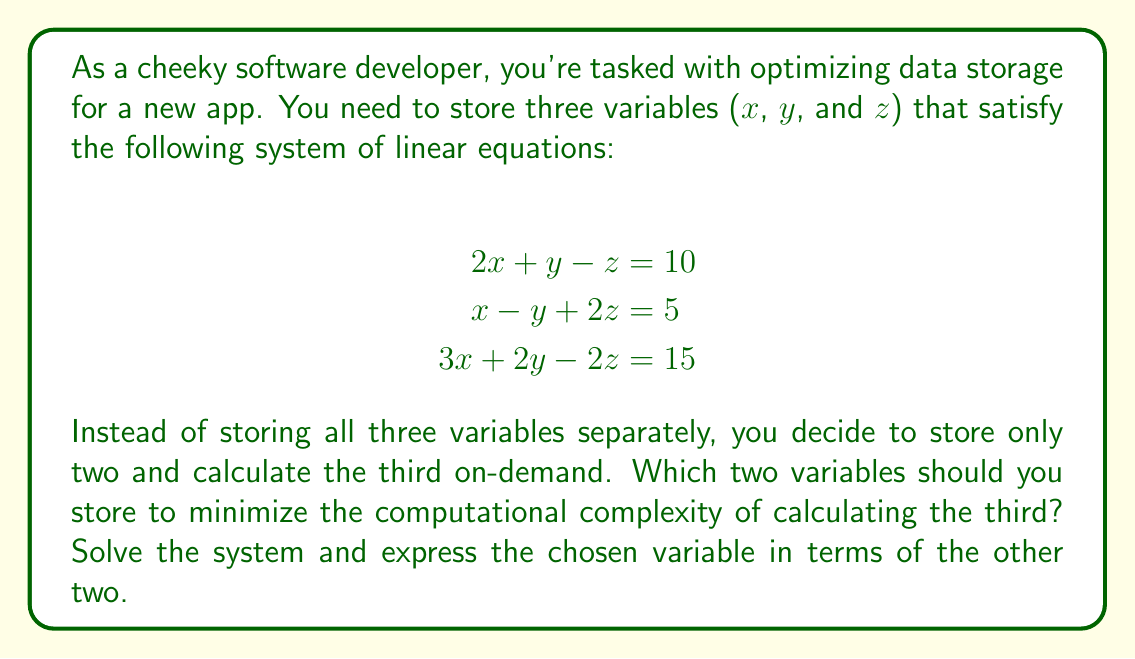Help me with this question. Let's approach this step-by-step:

1) First, we need to solve the system of equations. We'll use elimination method.

2) Multiply the first equation by 2 and the second equation by 3:

   $$\begin{align}
   4x + 2y - 2z &= 20 \\
   3x - 3y + 6z &= 15
   \end{align}$$

3) Add these equations to eliminate $z$:

   $$7x - y = 35$$

4) Now, use this equation with the first original equation:

   $$\begin{align}
   7x - y &= 35 \\
   2x + y - z &= 10
   \end{align}$$

5) Add these equations to eliminate $y$:

   $$9x - z = 45$$

6) We now have $x$ in terms of $z$:

   $$x = 5 + \frac{1}{9}z$$

7) Substitute this into the second original equation:

   $$(5 + \frac{1}{9}z) - y + 2z = 5$$

8) Simplify:

   $$5 + \frac{1}{9}z - y + 2z = 5$$
   $$\frac{1}{9}z - y + 2z = 0$$
   $$\frac{19}{9}z - y = 0$$
   $$y = \frac{19}{9}z$$

9) Now we have $x$ and $y$ in terms of $z$:

   $$\begin{align}
   x &= 5 + \frac{1}{9}z \\
   y &= \frac{19}{9}z
   \end{align}$$

To minimize computational complexity, we should store $z$ and either $x$ or $y$. Storing $z$ and $x$ would be slightly more efficient as calculating $y$ from $z$ requires fewer operations than calculating $x$ from $z$.
Answer: Store $z$ and $x$. Express $y$ in terms of $z$: $y = \frac{19}{9}z$ 